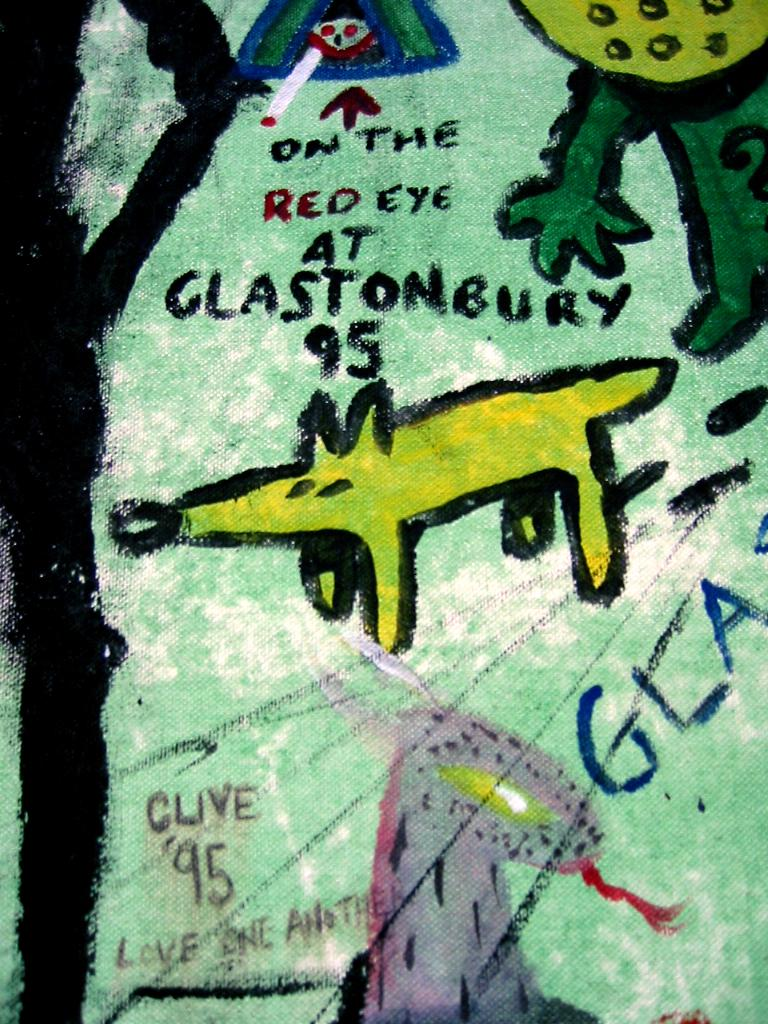Provide a one-sentence caption for the provided image. A cartoon depiction of a dog with the words On the red eye at Glastonbury 95 written above it. 